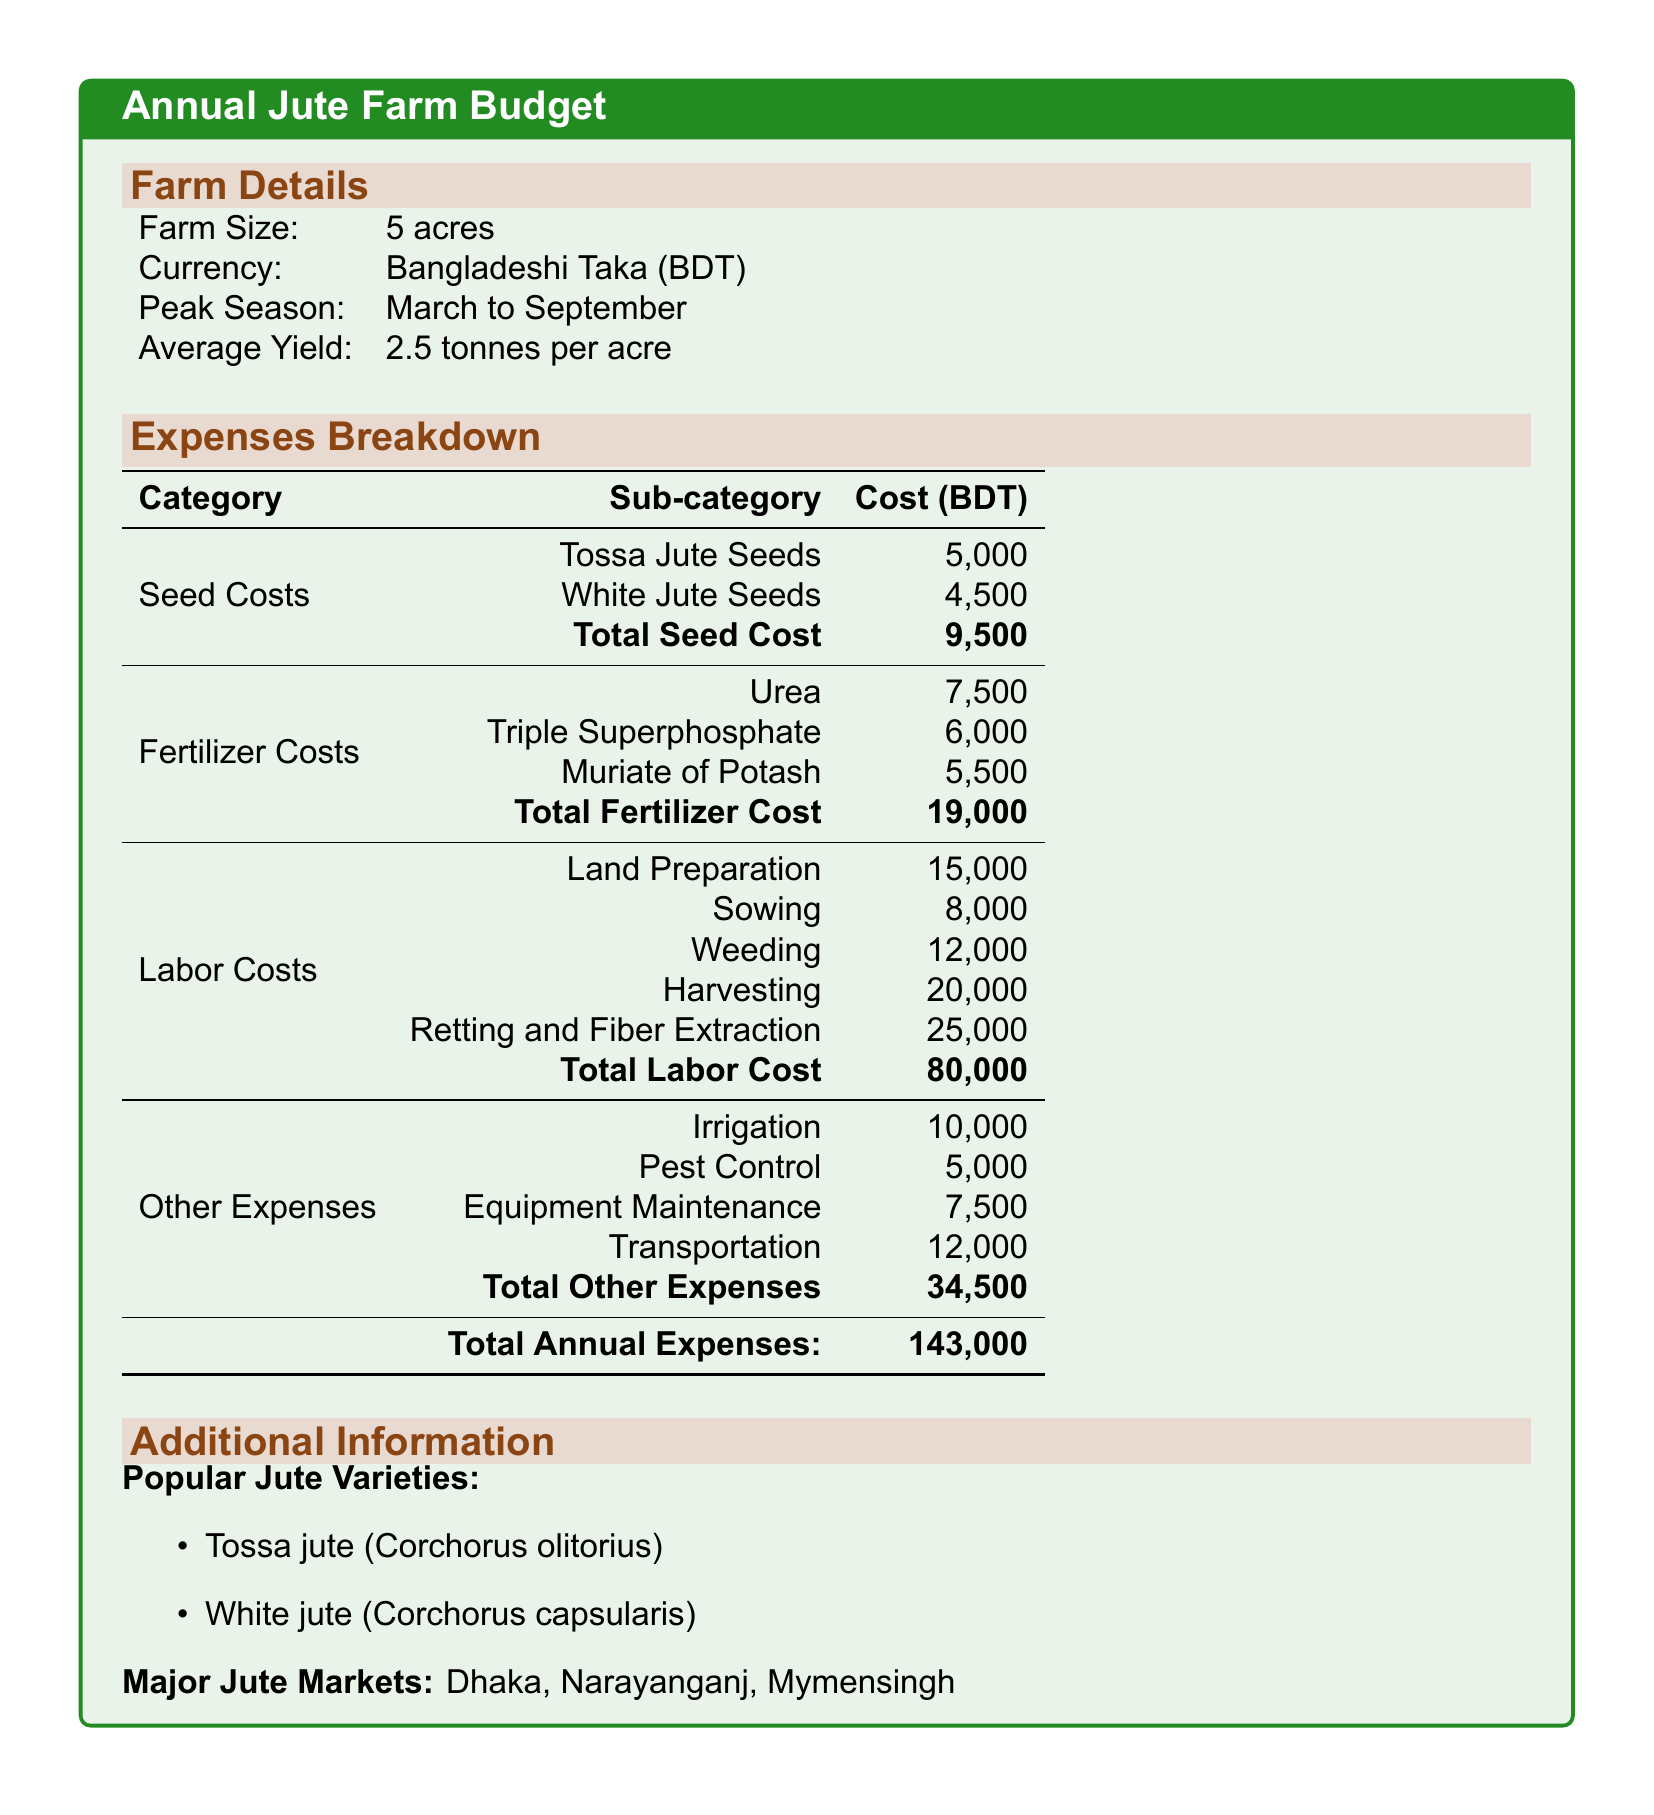what is the total seed cost? The total seed cost is listed in the document under Seed Costs, combining Tossa and White jute seed costs.
Answer: 9,500 how much does Urea cost? Urea cost is specified under Fertilizer Costs as one of the items.
Answer: 7,500 what is the average yield per acre? The average yield per acre is mentioned in the Farm Details section of the document.
Answer: 2.5 tonnes which variety of jute costs more for seeds? The document provides separate costs for Tossa and White jute seeds, which can be compared.
Answer: Tossa Jute Seeds what is the total labor cost? The total labor cost is the sum of all labor-related expenses listed in the Expenses Breakdown.
Answer: 80,000 how much is spent on pest control? Pest control is categorized under Other Expenses, detailing its specific cost.
Answer: 5,000 what is the total amount for other expenses? The total for other expenses includes multiple items in that category, which are summed up.
Answer: 34,500 what are the major jute markets mentioned? The document lists specific major jute markets in conjunction with popular jute varieties.
Answer: Dhaka, Narayanganj, Mymensingh what is the peak season for jute farming? The peak season is explicitly stated in the Farm Details section, indicating the optimal time for farming jute.
Answer: March to September how many acres is the farm? The size of the farm is provided directly in the Farm Details part of the document.
Answer: 5 acres 